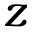<formula> <loc_0><loc_0><loc_500><loc_500>z</formula> 